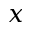<formula> <loc_0><loc_0><loc_500><loc_500>x</formula> 